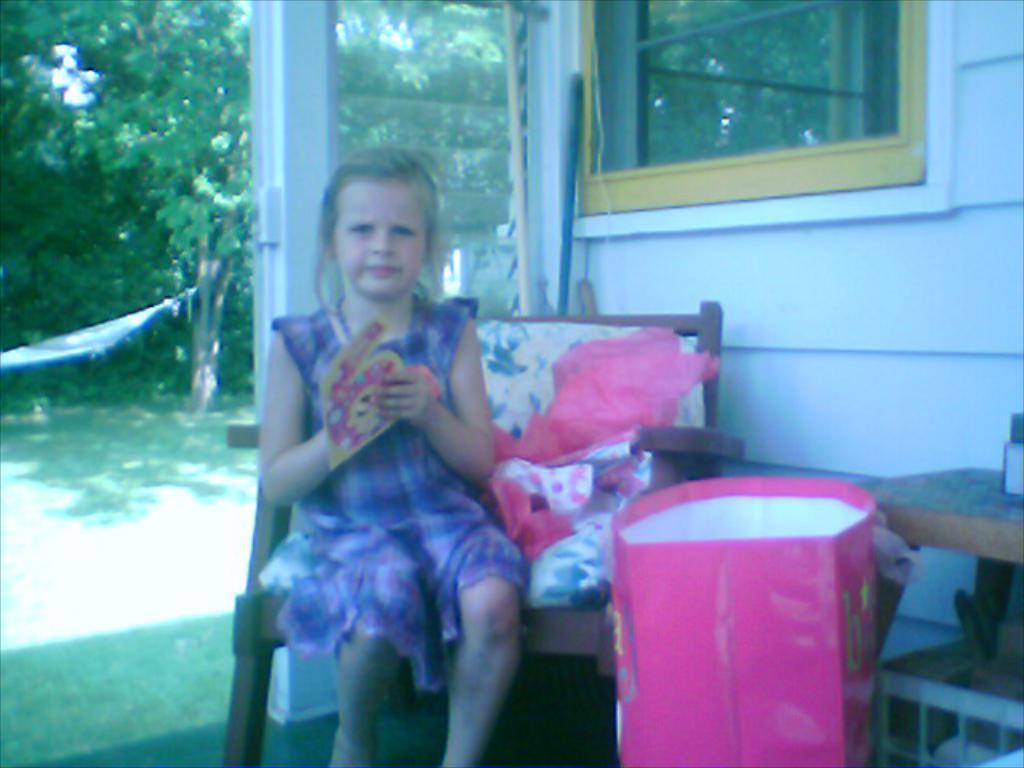Describe this image in one or two sentences. In this image we can see a girl is sitting on the chair. In the background, we can see the wall, trees and a window. We can see the grassy land on the left side of the image. There is a carry bag and a table in the right bottom of the image. We can see some objects on the chair and on the table. 